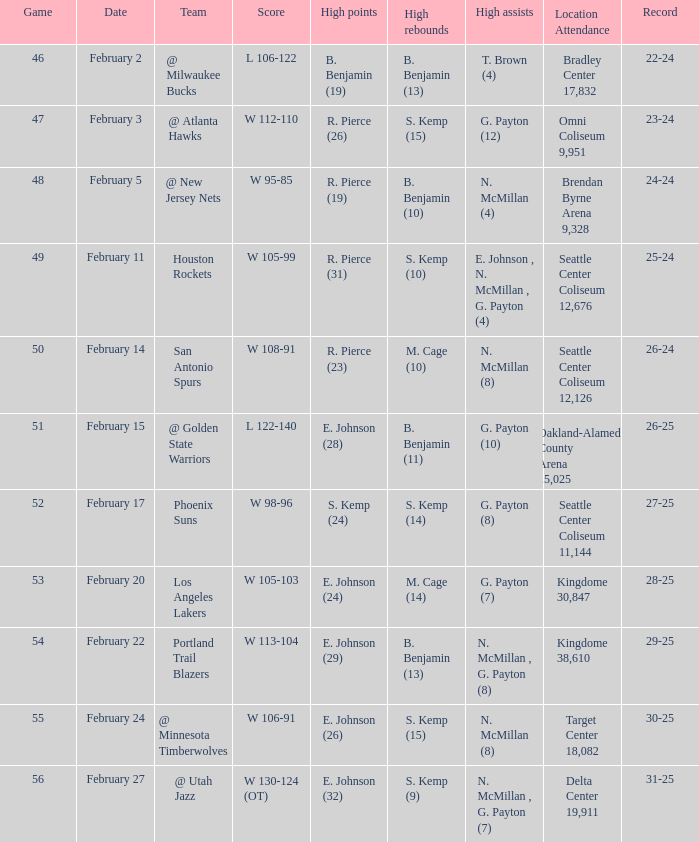On which date did the game take place at seattle center coliseum with a crowd of 12,126? February 14. 